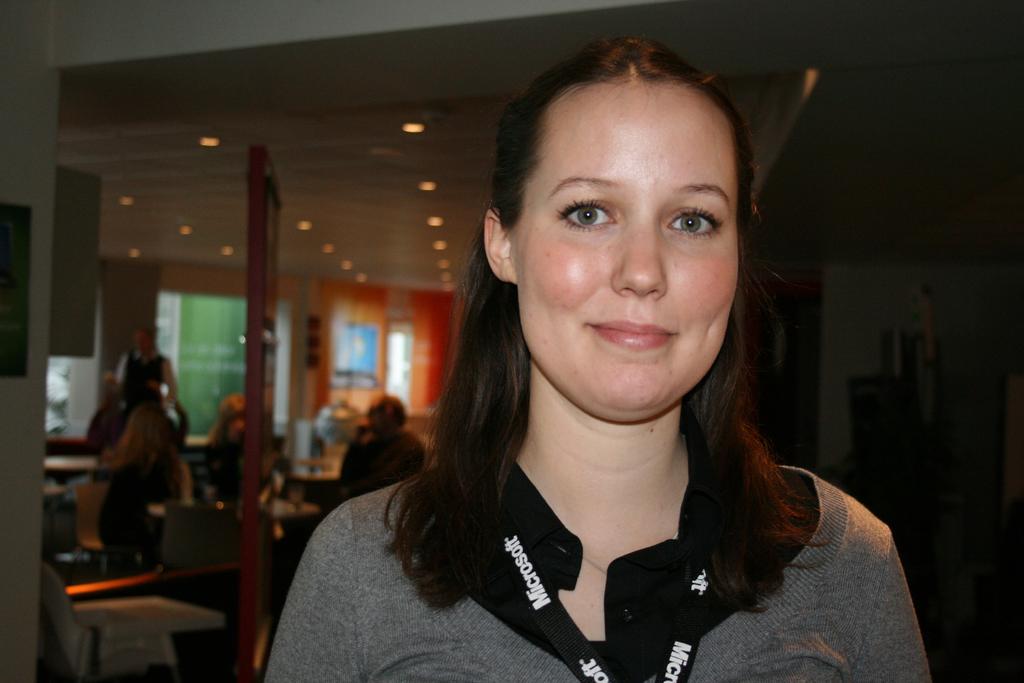What are the first four letters of the company's name?
Ensure brevity in your answer.  Micr. 